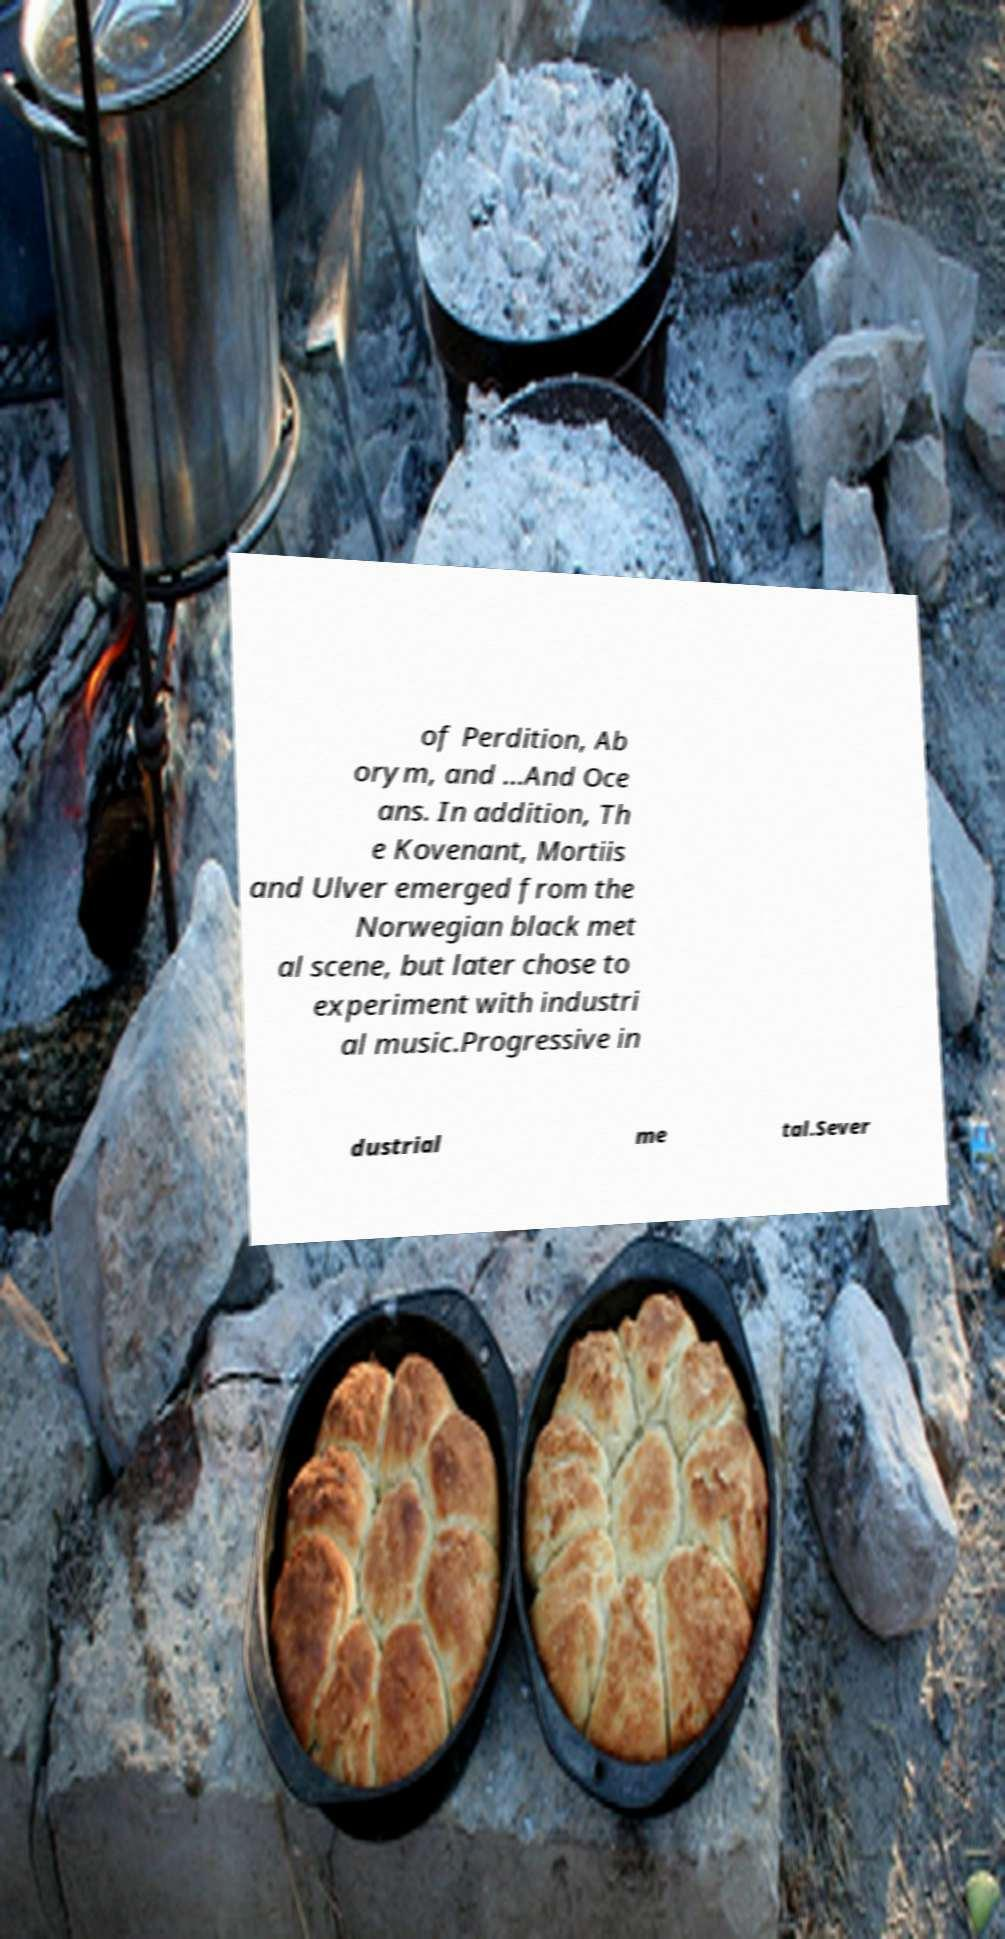Please read and relay the text visible in this image. What does it say? of Perdition, Ab orym, and ...And Oce ans. In addition, Th e Kovenant, Mortiis and Ulver emerged from the Norwegian black met al scene, but later chose to experiment with industri al music.Progressive in dustrial me tal.Sever 